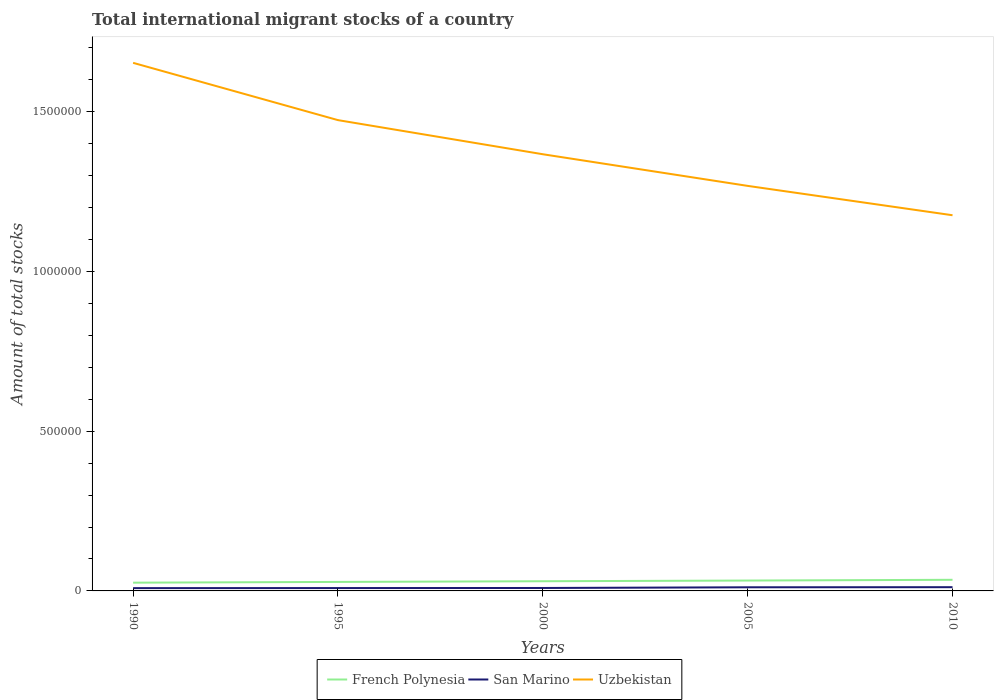Is the number of lines equal to the number of legend labels?
Provide a short and direct response. Yes. Across all years, what is the maximum amount of total stocks in in San Marino?
Make the answer very short. 8745. What is the total amount of total stocks in in Uzbekistan in the graph?
Your response must be concise. 2.86e+05. What is the difference between the highest and the second highest amount of total stocks in in French Polynesia?
Offer a very short reply. 8973. What is the difference between the highest and the lowest amount of total stocks in in Uzbekistan?
Your answer should be compact. 2. How many years are there in the graph?
Provide a succinct answer. 5. Are the values on the major ticks of Y-axis written in scientific E-notation?
Keep it short and to the point. No. How many legend labels are there?
Make the answer very short. 3. What is the title of the graph?
Your answer should be compact. Total international migrant stocks of a country. Does "Iran" appear as one of the legend labels in the graph?
Provide a short and direct response. No. What is the label or title of the X-axis?
Keep it short and to the point. Years. What is the label or title of the Y-axis?
Offer a very short reply. Amount of total stocks. What is the Amount of total stocks in French Polynesia in 1990?
Make the answer very short. 2.58e+04. What is the Amount of total stocks in San Marino in 1990?
Offer a very short reply. 8745. What is the Amount of total stocks in Uzbekistan in 1990?
Ensure brevity in your answer.  1.65e+06. What is the Amount of total stocks in French Polynesia in 1995?
Your response must be concise. 2.82e+04. What is the Amount of total stocks in San Marino in 1995?
Your answer should be very brief. 8966. What is the Amount of total stocks in Uzbekistan in 1995?
Give a very brief answer. 1.47e+06. What is the Amount of total stocks in French Polynesia in 2000?
Give a very brief answer. 3.03e+04. What is the Amount of total stocks of San Marino in 2000?
Keep it short and to the point. 9192. What is the Amount of total stocks in Uzbekistan in 2000?
Your answer should be very brief. 1.37e+06. What is the Amount of total stocks of French Polynesia in 2005?
Your answer should be very brief. 3.25e+04. What is the Amount of total stocks of San Marino in 2005?
Ensure brevity in your answer.  1.14e+04. What is the Amount of total stocks of Uzbekistan in 2005?
Your answer should be very brief. 1.27e+06. What is the Amount of total stocks in French Polynesia in 2010?
Provide a succinct answer. 3.48e+04. What is the Amount of total stocks of San Marino in 2010?
Your answer should be compact. 1.17e+04. What is the Amount of total stocks in Uzbekistan in 2010?
Your answer should be compact. 1.18e+06. Across all years, what is the maximum Amount of total stocks in French Polynesia?
Provide a succinct answer. 3.48e+04. Across all years, what is the maximum Amount of total stocks in San Marino?
Keep it short and to the point. 1.17e+04. Across all years, what is the maximum Amount of total stocks in Uzbekistan?
Your response must be concise. 1.65e+06. Across all years, what is the minimum Amount of total stocks of French Polynesia?
Give a very brief answer. 2.58e+04. Across all years, what is the minimum Amount of total stocks in San Marino?
Give a very brief answer. 8745. Across all years, what is the minimum Amount of total stocks in Uzbekistan?
Your response must be concise. 1.18e+06. What is the total Amount of total stocks of French Polynesia in the graph?
Ensure brevity in your answer.  1.52e+05. What is the total Amount of total stocks of San Marino in the graph?
Offer a terse response. 5.00e+04. What is the total Amount of total stocks of Uzbekistan in the graph?
Your answer should be compact. 6.94e+06. What is the difference between the Amount of total stocks in French Polynesia in 1990 and that in 1995?
Your response must be concise. -2359. What is the difference between the Amount of total stocks of San Marino in 1990 and that in 1995?
Offer a very short reply. -221. What is the difference between the Amount of total stocks in Uzbekistan in 1990 and that in 1995?
Provide a short and direct response. 1.79e+05. What is the difference between the Amount of total stocks of French Polynesia in 1990 and that in 2000?
Make the answer very short. -4499. What is the difference between the Amount of total stocks in San Marino in 1990 and that in 2000?
Provide a succinct answer. -447. What is the difference between the Amount of total stocks in Uzbekistan in 1990 and that in 2000?
Provide a short and direct response. 2.86e+05. What is the difference between the Amount of total stocks of French Polynesia in 1990 and that in 2005?
Make the answer very short. -6659. What is the difference between the Amount of total stocks in San Marino in 1990 and that in 2005?
Ensure brevity in your answer.  -2651. What is the difference between the Amount of total stocks of Uzbekistan in 1990 and that in 2005?
Keep it short and to the point. 3.85e+05. What is the difference between the Amount of total stocks of French Polynesia in 1990 and that in 2010?
Offer a very short reply. -8973. What is the difference between the Amount of total stocks of San Marino in 1990 and that in 2010?
Provide a succinct answer. -2938. What is the difference between the Amount of total stocks of Uzbekistan in 1990 and that in 2010?
Your answer should be compact. 4.77e+05. What is the difference between the Amount of total stocks in French Polynesia in 1995 and that in 2000?
Your response must be concise. -2140. What is the difference between the Amount of total stocks of San Marino in 1995 and that in 2000?
Offer a very short reply. -226. What is the difference between the Amount of total stocks of Uzbekistan in 1995 and that in 2000?
Provide a succinct answer. 1.07e+05. What is the difference between the Amount of total stocks in French Polynesia in 1995 and that in 2005?
Make the answer very short. -4300. What is the difference between the Amount of total stocks in San Marino in 1995 and that in 2005?
Offer a very short reply. -2430. What is the difference between the Amount of total stocks of Uzbekistan in 1995 and that in 2005?
Offer a very short reply. 2.06e+05. What is the difference between the Amount of total stocks in French Polynesia in 1995 and that in 2010?
Make the answer very short. -6614. What is the difference between the Amount of total stocks of San Marino in 1995 and that in 2010?
Offer a terse response. -2717. What is the difference between the Amount of total stocks in Uzbekistan in 1995 and that in 2010?
Provide a succinct answer. 2.98e+05. What is the difference between the Amount of total stocks in French Polynesia in 2000 and that in 2005?
Make the answer very short. -2160. What is the difference between the Amount of total stocks in San Marino in 2000 and that in 2005?
Your answer should be very brief. -2204. What is the difference between the Amount of total stocks of Uzbekistan in 2000 and that in 2005?
Offer a very short reply. 9.91e+04. What is the difference between the Amount of total stocks in French Polynesia in 2000 and that in 2010?
Make the answer very short. -4474. What is the difference between the Amount of total stocks of San Marino in 2000 and that in 2010?
Your answer should be compact. -2491. What is the difference between the Amount of total stocks of Uzbekistan in 2000 and that in 2010?
Offer a terse response. 1.91e+05. What is the difference between the Amount of total stocks in French Polynesia in 2005 and that in 2010?
Give a very brief answer. -2314. What is the difference between the Amount of total stocks in San Marino in 2005 and that in 2010?
Offer a terse response. -287. What is the difference between the Amount of total stocks in Uzbekistan in 2005 and that in 2010?
Provide a succinct answer. 9.19e+04. What is the difference between the Amount of total stocks of French Polynesia in 1990 and the Amount of total stocks of San Marino in 1995?
Your answer should be very brief. 1.69e+04. What is the difference between the Amount of total stocks of French Polynesia in 1990 and the Amount of total stocks of Uzbekistan in 1995?
Your answer should be compact. -1.45e+06. What is the difference between the Amount of total stocks of San Marino in 1990 and the Amount of total stocks of Uzbekistan in 1995?
Ensure brevity in your answer.  -1.46e+06. What is the difference between the Amount of total stocks of French Polynesia in 1990 and the Amount of total stocks of San Marino in 2000?
Provide a short and direct response. 1.66e+04. What is the difference between the Amount of total stocks of French Polynesia in 1990 and the Amount of total stocks of Uzbekistan in 2000?
Provide a succinct answer. -1.34e+06. What is the difference between the Amount of total stocks of San Marino in 1990 and the Amount of total stocks of Uzbekistan in 2000?
Provide a short and direct response. -1.36e+06. What is the difference between the Amount of total stocks in French Polynesia in 1990 and the Amount of total stocks in San Marino in 2005?
Ensure brevity in your answer.  1.44e+04. What is the difference between the Amount of total stocks in French Polynesia in 1990 and the Amount of total stocks in Uzbekistan in 2005?
Your answer should be very brief. -1.24e+06. What is the difference between the Amount of total stocks in San Marino in 1990 and the Amount of total stocks in Uzbekistan in 2005?
Your answer should be very brief. -1.26e+06. What is the difference between the Amount of total stocks of French Polynesia in 1990 and the Amount of total stocks of San Marino in 2010?
Make the answer very short. 1.41e+04. What is the difference between the Amount of total stocks of French Polynesia in 1990 and the Amount of total stocks of Uzbekistan in 2010?
Your answer should be very brief. -1.15e+06. What is the difference between the Amount of total stocks of San Marino in 1990 and the Amount of total stocks of Uzbekistan in 2010?
Your response must be concise. -1.17e+06. What is the difference between the Amount of total stocks of French Polynesia in 1995 and the Amount of total stocks of San Marino in 2000?
Offer a very short reply. 1.90e+04. What is the difference between the Amount of total stocks in French Polynesia in 1995 and the Amount of total stocks in Uzbekistan in 2000?
Keep it short and to the point. -1.34e+06. What is the difference between the Amount of total stocks in San Marino in 1995 and the Amount of total stocks in Uzbekistan in 2000?
Offer a terse response. -1.36e+06. What is the difference between the Amount of total stocks in French Polynesia in 1995 and the Amount of total stocks in San Marino in 2005?
Give a very brief answer. 1.68e+04. What is the difference between the Amount of total stocks in French Polynesia in 1995 and the Amount of total stocks in Uzbekistan in 2005?
Your answer should be compact. -1.24e+06. What is the difference between the Amount of total stocks in San Marino in 1995 and the Amount of total stocks in Uzbekistan in 2005?
Offer a terse response. -1.26e+06. What is the difference between the Amount of total stocks in French Polynesia in 1995 and the Amount of total stocks in San Marino in 2010?
Offer a terse response. 1.65e+04. What is the difference between the Amount of total stocks of French Polynesia in 1995 and the Amount of total stocks of Uzbekistan in 2010?
Your response must be concise. -1.15e+06. What is the difference between the Amount of total stocks in San Marino in 1995 and the Amount of total stocks in Uzbekistan in 2010?
Ensure brevity in your answer.  -1.17e+06. What is the difference between the Amount of total stocks in French Polynesia in 2000 and the Amount of total stocks in San Marino in 2005?
Provide a succinct answer. 1.89e+04. What is the difference between the Amount of total stocks in French Polynesia in 2000 and the Amount of total stocks in Uzbekistan in 2005?
Your answer should be very brief. -1.24e+06. What is the difference between the Amount of total stocks in San Marino in 2000 and the Amount of total stocks in Uzbekistan in 2005?
Provide a succinct answer. -1.26e+06. What is the difference between the Amount of total stocks in French Polynesia in 2000 and the Amount of total stocks in San Marino in 2010?
Keep it short and to the point. 1.86e+04. What is the difference between the Amount of total stocks of French Polynesia in 2000 and the Amount of total stocks of Uzbekistan in 2010?
Provide a succinct answer. -1.15e+06. What is the difference between the Amount of total stocks of San Marino in 2000 and the Amount of total stocks of Uzbekistan in 2010?
Ensure brevity in your answer.  -1.17e+06. What is the difference between the Amount of total stocks in French Polynesia in 2005 and the Amount of total stocks in San Marino in 2010?
Give a very brief answer. 2.08e+04. What is the difference between the Amount of total stocks in French Polynesia in 2005 and the Amount of total stocks in Uzbekistan in 2010?
Offer a very short reply. -1.14e+06. What is the difference between the Amount of total stocks in San Marino in 2005 and the Amount of total stocks in Uzbekistan in 2010?
Your answer should be very brief. -1.16e+06. What is the average Amount of total stocks of French Polynesia per year?
Your response must be concise. 3.03e+04. What is the average Amount of total stocks in San Marino per year?
Give a very brief answer. 9996.4. What is the average Amount of total stocks of Uzbekistan per year?
Your answer should be compact. 1.39e+06. In the year 1990, what is the difference between the Amount of total stocks of French Polynesia and Amount of total stocks of San Marino?
Provide a short and direct response. 1.71e+04. In the year 1990, what is the difference between the Amount of total stocks of French Polynesia and Amount of total stocks of Uzbekistan?
Ensure brevity in your answer.  -1.63e+06. In the year 1990, what is the difference between the Amount of total stocks in San Marino and Amount of total stocks in Uzbekistan?
Ensure brevity in your answer.  -1.64e+06. In the year 1995, what is the difference between the Amount of total stocks in French Polynesia and Amount of total stocks in San Marino?
Give a very brief answer. 1.92e+04. In the year 1995, what is the difference between the Amount of total stocks in French Polynesia and Amount of total stocks in Uzbekistan?
Keep it short and to the point. -1.45e+06. In the year 1995, what is the difference between the Amount of total stocks of San Marino and Amount of total stocks of Uzbekistan?
Offer a very short reply. -1.46e+06. In the year 2000, what is the difference between the Amount of total stocks in French Polynesia and Amount of total stocks in San Marino?
Your answer should be compact. 2.11e+04. In the year 2000, what is the difference between the Amount of total stocks of French Polynesia and Amount of total stocks of Uzbekistan?
Your answer should be compact. -1.34e+06. In the year 2000, what is the difference between the Amount of total stocks in San Marino and Amount of total stocks in Uzbekistan?
Make the answer very short. -1.36e+06. In the year 2005, what is the difference between the Amount of total stocks of French Polynesia and Amount of total stocks of San Marino?
Your answer should be compact. 2.11e+04. In the year 2005, what is the difference between the Amount of total stocks in French Polynesia and Amount of total stocks in Uzbekistan?
Offer a very short reply. -1.24e+06. In the year 2005, what is the difference between the Amount of total stocks of San Marino and Amount of total stocks of Uzbekistan?
Offer a terse response. -1.26e+06. In the year 2010, what is the difference between the Amount of total stocks of French Polynesia and Amount of total stocks of San Marino?
Your response must be concise. 2.31e+04. In the year 2010, what is the difference between the Amount of total stocks in French Polynesia and Amount of total stocks in Uzbekistan?
Give a very brief answer. -1.14e+06. In the year 2010, what is the difference between the Amount of total stocks in San Marino and Amount of total stocks in Uzbekistan?
Make the answer very short. -1.16e+06. What is the ratio of the Amount of total stocks of French Polynesia in 1990 to that in 1995?
Your answer should be compact. 0.92. What is the ratio of the Amount of total stocks of San Marino in 1990 to that in 1995?
Provide a succinct answer. 0.98. What is the ratio of the Amount of total stocks of Uzbekistan in 1990 to that in 1995?
Provide a succinct answer. 1.12. What is the ratio of the Amount of total stocks in French Polynesia in 1990 to that in 2000?
Offer a very short reply. 0.85. What is the ratio of the Amount of total stocks of San Marino in 1990 to that in 2000?
Provide a short and direct response. 0.95. What is the ratio of the Amount of total stocks of Uzbekistan in 1990 to that in 2000?
Keep it short and to the point. 1.21. What is the ratio of the Amount of total stocks of French Polynesia in 1990 to that in 2005?
Your answer should be very brief. 0.8. What is the ratio of the Amount of total stocks in San Marino in 1990 to that in 2005?
Your answer should be very brief. 0.77. What is the ratio of the Amount of total stocks of Uzbekistan in 1990 to that in 2005?
Offer a very short reply. 1.3. What is the ratio of the Amount of total stocks of French Polynesia in 1990 to that in 2010?
Provide a succinct answer. 0.74. What is the ratio of the Amount of total stocks of San Marino in 1990 to that in 2010?
Make the answer very short. 0.75. What is the ratio of the Amount of total stocks of Uzbekistan in 1990 to that in 2010?
Your answer should be compact. 1.41. What is the ratio of the Amount of total stocks in French Polynesia in 1995 to that in 2000?
Make the answer very short. 0.93. What is the ratio of the Amount of total stocks of San Marino in 1995 to that in 2000?
Provide a short and direct response. 0.98. What is the ratio of the Amount of total stocks in Uzbekistan in 1995 to that in 2000?
Offer a very short reply. 1.08. What is the ratio of the Amount of total stocks in French Polynesia in 1995 to that in 2005?
Give a very brief answer. 0.87. What is the ratio of the Amount of total stocks in San Marino in 1995 to that in 2005?
Make the answer very short. 0.79. What is the ratio of the Amount of total stocks in Uzbekistan in 1995 to that in 2005?
Offer a terse response. 1.16. What is the ratio of the Amount of total stocks in French Polynesia in 1995 to that in 2010?
Your answer should be compact. 0.81. What is the ratio of the Amount of total stocks in San Marino in 1995 to that in 2010?
Give a very brief answer. 0.77. What is the ratio of the Amount of total stocks of Uzbekistan in 1995 to that in 2010?
Make the answer very short. 1.25. What is the ratio of the Amount of total stocks in French Polynesia in 2000 to that in 2005?
Ensure brevity in your answer.  0.93. What is the ratio of the Amount of total stocks of San Marino in 2000 to that in 2005?
Offer a very short reply. 0.81. What is the ratio of the Amount of total stocks of Uzbekistan in 2000 to that in 2005?
Give a very brief answer. 1.08. What is the ratio of the Amount of total stocks in French Polynesia in 2000 to that in 2010?
Offer a terse response. 0.87. What is the ratio of the Amount of total stocks of San Marino in 2000 to that in 2010?
Make the answer very short. 0.79. What is the ratio of the Amount of total stocks of Uzbekistan in 2000 to that in 2010?
Ensure brevity in your answer.  1.16. What is the ratio of the Amount of total stocks in French Polynesia in 2005 to that in 2010?
Your response must be concise. 0.93. What is the ratio of the Amount of total stocks in San Marino in 2005 to that in 2010?
Offer a very short reply. 0.98. What is the ratio of the Amount of total stocks in Uzbekistan in 2005 to that in 2010?
Your answer should be very brief. 1.08. What is the difference between the highest and the second highest Amount of total stocks of French Polynesia?
Provide a succinct answer. 2314. What is the difference between the highest and the second highest Amount of total stocks in San Marino?
Keep it short and to the point. 287. What is the difference between the highest and the second highest Amount of total stocks of Uzbekistan?
Provide a short and direct response. 1.79e+05. What is the difference between the highest and the lowest Amount of total stocks of French Polynesia?
Offer a very short reply. 8973. What is the difference between the highest and the lowest Amount of total stocks of San Marino?
Your response must be concise. 2938. What is the difference between the highest and the lowest Amount of total stocks in Uzbekistan?
Your response must be concise. 4.77e+05. 